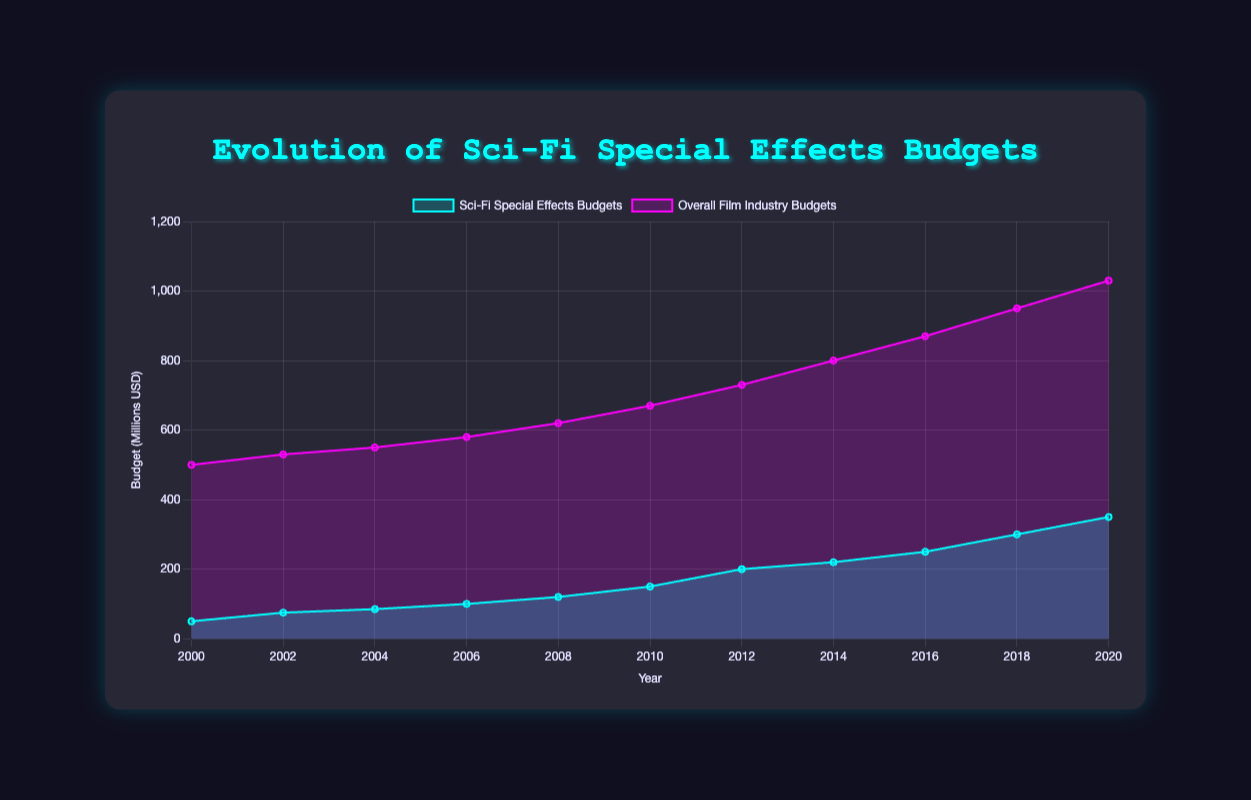How many years are represented in the chart? Count the data points on the x-axis. There are 11 distinct years listed, from 2000 to 2020.
Answer: 11 What is the title of the chart? Read the title at the top of the chart. It is "Evolution of Sci-Fi Special Effects Budgets".
Answer: Evolution of Sci-Fi Special Effects Budgets Which year had the highest budget for sci-fi special effects? Look at the highest point of the "Sci-Fi Special Effects Budgets" line. The highest budget is in 2020 with a value of 350 million USD.
Answer: 2020 What is the trend of the overall film industry budgets from 2000 to 2020? Observe the trend line for "Overall Film Industry Budgets". It shows a consistent increase from 500 million USD in 2000 to 1030 million USD in 2020.
Answer: Increasing How does the sci-fi special effects budget in 2010 compare with that in 2000? Compare the budget values for both years. The budget for 2010 is 150 million USD, and for 2000 it is 50 million USD. The budget in 2010 is three times higher than in 2000.
Answer: 3 times higher Which year marks a significant increase in sci-fi special effects budgets? Look for a noticeable upward change in the "Sci-Fi Special Effects Budgets" line. The year 2010 shows a significant increase from 120 million USD in 2008 to 150 million USD.
Answer: 2010 What's the difference in budget between sci-fi special effects and the overall film industry in 2006? Subtract the sci-fi special effects budget from the overall film industry budget for 2006. The difference is 580 million USD (overall) - 100 million USD (sci-fi) = 480 million USD.
Answer: 480 million USD In which year did the overall film industry budget surpass 800 million USD? Find the year at which the "Overall Film Industry Budgets" line crosses 800 million USD. It happens in 2014, where the budget is 800 million USD.
Answer: 2014 What can you infer about the relationship between sci-fi special effects budgets and overall film industry budgets? Notice both trends from 2000 to 2020. Both budgets have generally increased, suggesting a parallel growth, but sci-fi special effects budgets have grown at a higher rate in the latter years.
Answer: Parallel growth, higher rate for sci-fi Between 2008 and 2012, what is the average budget for sci-fi special effects? Add the budgets for 2008, 2010, and 2012, then divide by the number of years. (120 + 150 + 200) / 3 = 156.67 million USD.
Answer: 156.67 million USD 